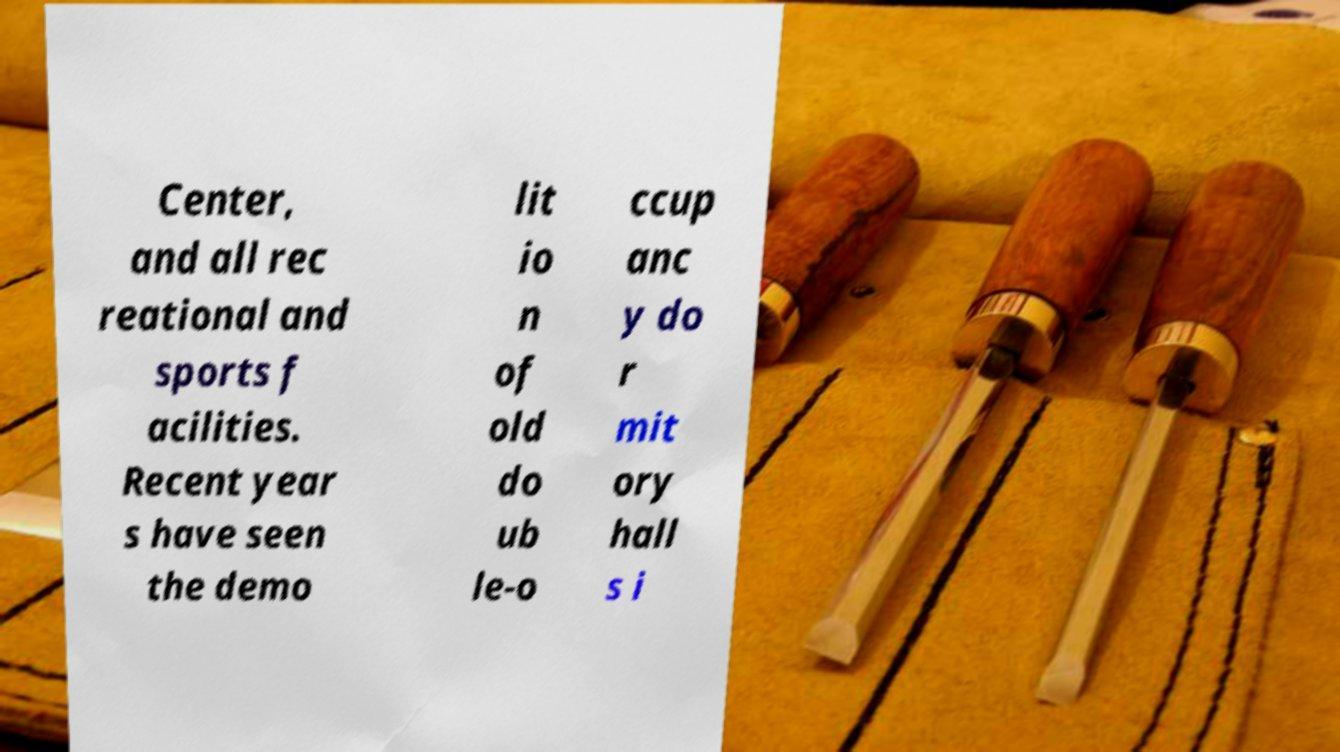There's text embedded in this image that I need extracted. Can you transcribe it verbatim? Center, and all rec reational and sports f acilities. Recent year s have seen the demo lit io n of old do ub le-o ccup anc y do r mit ory hall s i 